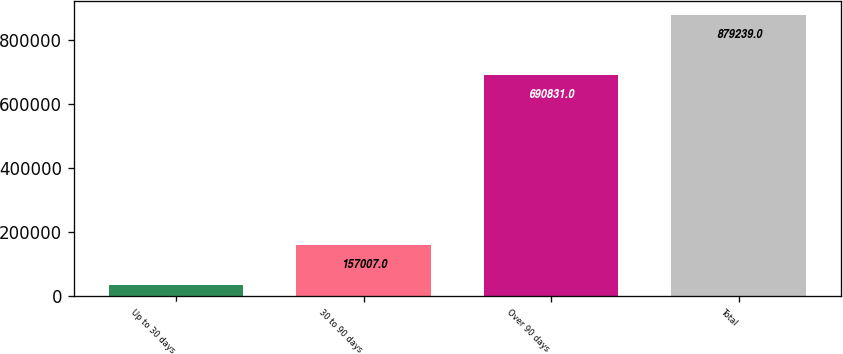Convert chart to OTSL. <chart><loc_0><loc_0><loc_500><loc_500><bar_chart><fcel>Up to 30 days<fcel>30 to 90 days<fcel>Over 90 days<fcel>Total<nl><fcel>31401<fcel>157007<fcel>690831<fcel>879239<nl></chart> 